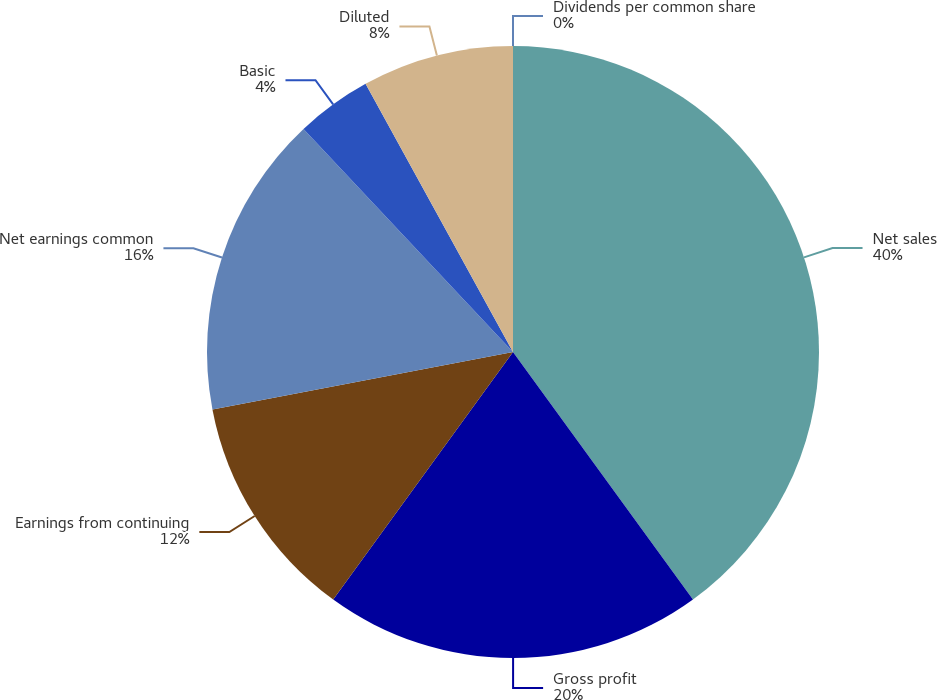<chart> <loc_0><loc_0><loc_500><loc_500><pie_chart><fcel>Net sales<fcel>Gross profit<fcel>Earnings from continuing<fcel>Net earnings common<fcel>Basic<fcel>Diluted<fcel>Dividends per common share<nl><fcel>39.99%<fcel>20.0%<fcel>12.0%<fcel>16.0%<fcel>4.0%<fcel>8.0%<fcel>0.0%<nl></chart> 